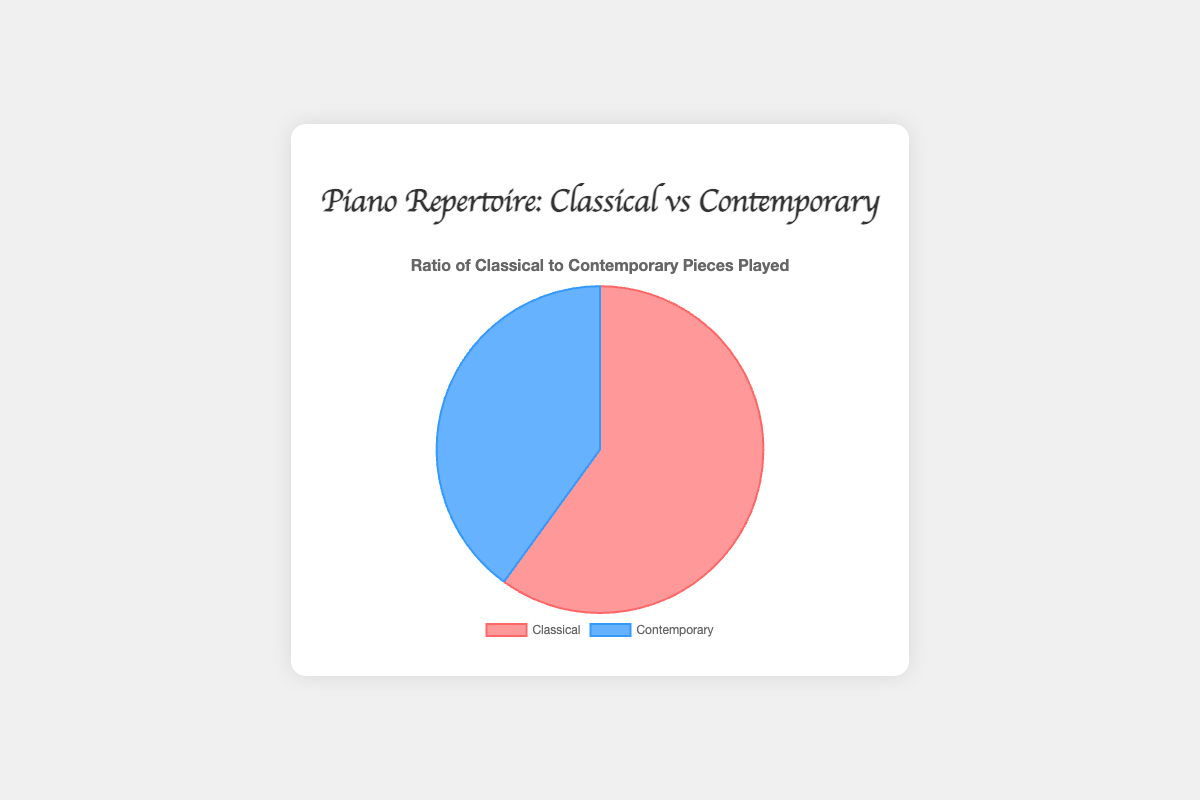What's the ratio of classical to contemporary pieces played? The figure shows two segments for classical and contemporary pieces. The classical segment represents 45 pieces, and the contemporary segment represents 30 pieces. The ratio can be expressed as 45:30, which simplifies to 3:2.
Answer: 3:2 Which category has more pieces played? The figure displays the total pieces played for classical as 45 and for contemporary as 30. Since 45 is greater than 30, the classical category has more pieces played.
Answer: Classical By how much is the number of classical pieces greater than the contemporary pieces? The figure shows 45 classical pieces and 30 contemporary pieces. To find the difference, subtract the number of contemporary pieces from the number of classical pieces: 45 - 30 = 15.
Answer: 15 What percentage of the repertoire are contemporary pieces? The total number of pieces played is the sum of classical and contemporary pieces, which is 45 + 30 = 75. The contemporary pieces are 30. To find the percentage: (30/75) * 100 = 40%.
Answer: 40% If you were to play an additional 10 contemporary pieces, how would the ratio of classical to contemporary pieces change? Currently, there are 45 classical pieces and 30 contemporary pieces. After playing 10 more contemporary pieces, there would be 40 contemporary pieces. The new ratio of classical to contemporary pieces would be 45:40, which simplifies to 9:8.
Answer: 9:8 What is the total number of pieces played in the repertoire? The figure indicates the number of pieces as 45 for classical and 30 for contemporary. Adding these numbers gives the total: 45 + 30 = 75.
Answer: 75 Which category is represented by the blue color in the pie chart? The figure's visual attributes show blue color representing 30 pieces, which matches the number of contemporary pieces. Therefore, the blue color represents the contemporary category.
Answer: Contemporary Are there more classical pieces played by more than 10 than contemporary pieces? By comparing the numbers, the classical pieces are 45 and the contemporary pieces are 30. The difference is 45 - 30 = 15. Since 15 is greater than 10, there are more classical pieces by more than 10.
Answer: Yes If the repertoire consisted of an equal number of classical and contemporary pieces, how many more contemporary pieces would need to be played? For an equal number of pieces, both categories should have 45 pieces (the current number of classical pieces). The contemporary pieces are currently 30, so the additional pieces required are 45 - 30 = 15.
Answer: 15 